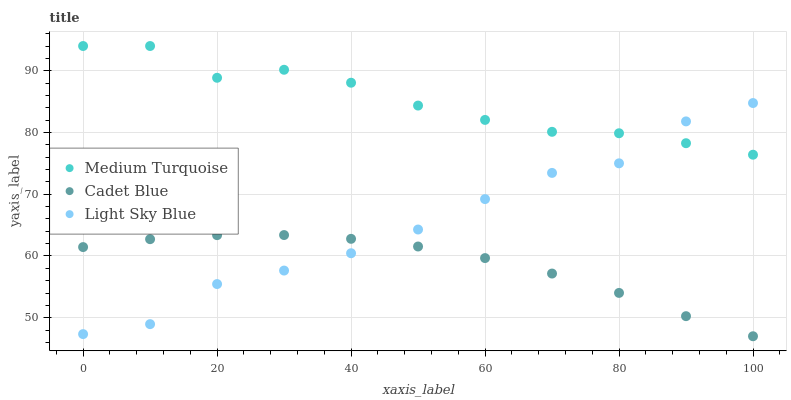Does Cadet Blue have the minimum area under the curve?
Answer yes or no. Yes. Does Medium Turquoise have the maximum area under the curve?
Answer yes or no. Yes. Does Light Sky Blue have the minimum area under the curve?
Answer yes or no. No. Does Light Sky Blue have the maximum area under the curve?
Answer yes or no. No. Is Cadet Blue the smoothest?
Answer yes or no. Yes. Is Light Sky Blue the roughest?
Answer yes or no. Yes. Is Medium Turquoise the smoothest?
Answer yes or no. No. Is Medium Turquoise the roughest?
Answer yes or no. No. Does Cadet Blue have the lowest value?
Answer yes or no. Yes. Does Light Sky Blue have the lowest value?
Answer yes or no. No. Does Medium Turquoise have the highest value?
Answer yes or no. Yes. Does Light Sky Blue have the highest value?
Answer yes or no. No. Is Cadet Blue less than Medium Turquoise?
Answer yes or no. Yes. Is Medium Turquoise greater than Cadet Blue?
Answer yes or no. Yes. Does Medium Turquoise intersect Light Sky Blue?
Answer yes or no. Yes. Is Medium Turquoise less than Light Sky Blue?
Answer yes or no. No. Is Medium Turquoise greater than Light Sky Blue?
Answer yes or no. No. Does Cadet Blue intersect Medium Turquoise?
Answer yes or no. No. 